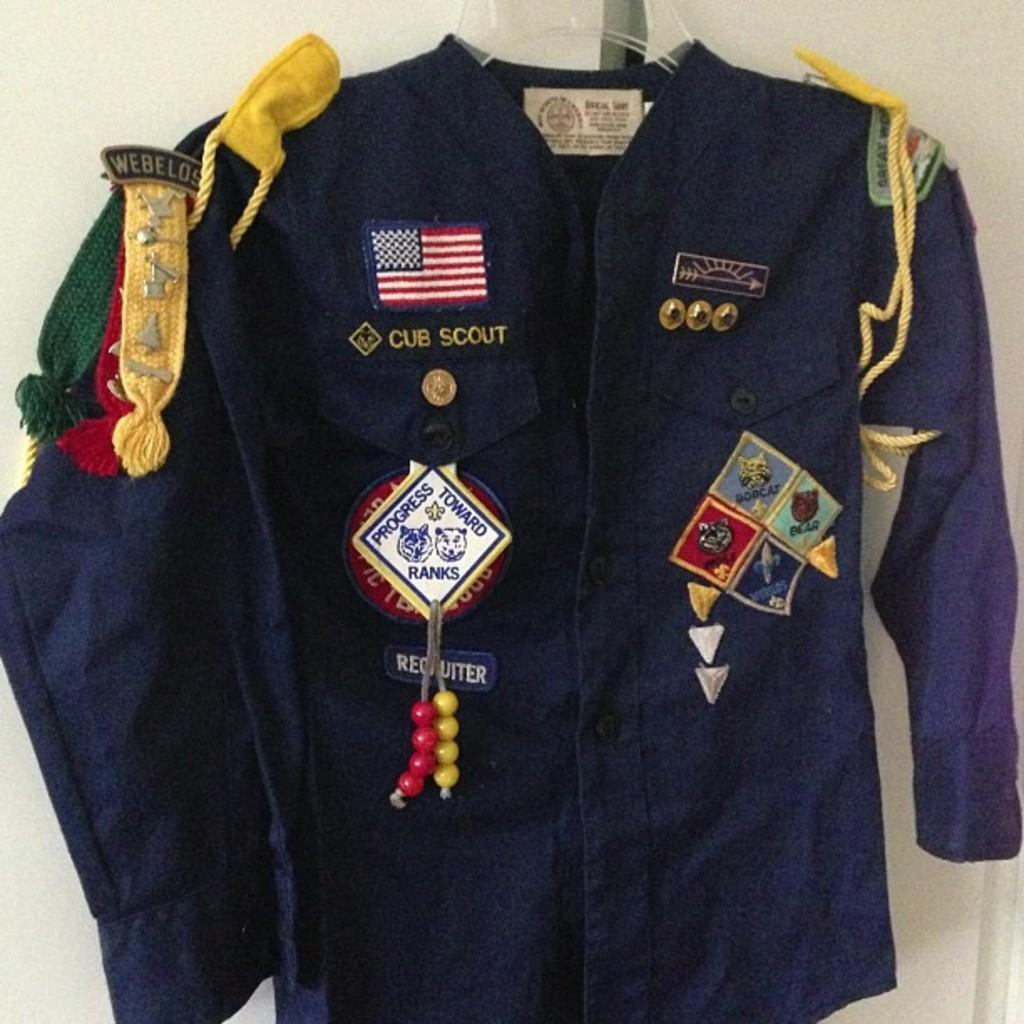<image>
Provide a brief description of the given image. a shirt that has the word scout on it 